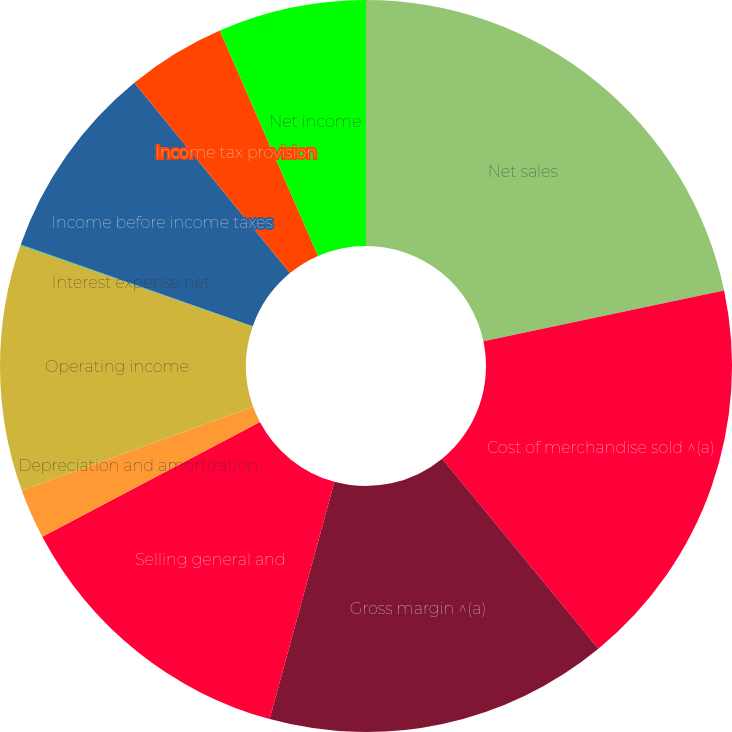Convert chart to OTSL. <chart><loc_0><loc_0><loc_500><loc_500><pie_chart><fcel>Net sales<fcel>Cost of merchandise sold ^(a)<fcel>Gross margin ^(a)<fcel>Selling general and<fcel>Depreciation and amortization<fcel>Operating income<fcel>Interest expense net<fcel>Income before income taxes<fcel>Income tax provision<fcel>Net income<nl><fcel>21.69%<fcel>17.36%<fcel>15.19%<fcel>13.03%<fcel>2.21%<fcel>10.87%<fcel>0.04%<fcel>8.7%<fcel>4.37%<fcel>6.54%<nl></chart> 